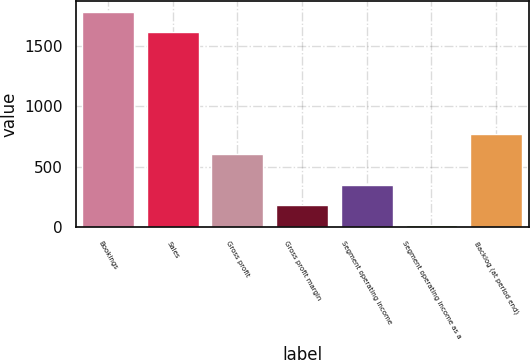Convert chart. <chart><loc_0><loc_0><loc_500><loc_500><bar_chart><fcel>Bookings<fcel>Sales<fcel>Gross profit<fcel>Gross profit margin<fcel>Segment operating income<fcel>Segment operating income as a<fcel>Backlog (at period end)<nl><fcel>1780.22<fcel>1615.7<fcel>603<fcel>184.52<fcel>349.04<fcel>20<fcel>774.8<nl></chart> 